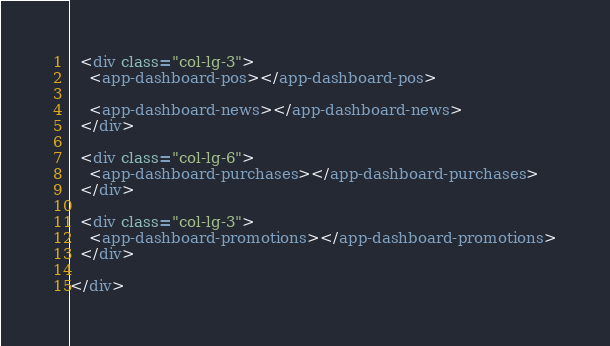Convert code to text. <code><loc_0><loc_0><loc_500><loc_500><_HTML_>  <div class="col-lg-3">
    <app-dashboard-pos></app-dashboard-pos>

    <app-dashboard-news></app-dashboard-news>
  </div>

  <div class="col-lg-6">
    <app-dashboard-purchases></app-dashboard-purchases>
  </div>

  <div class="col-lg-3">
    <app-dashboard-promotions></app-dashboard-promotions>
  </div>

</div>
</code> 